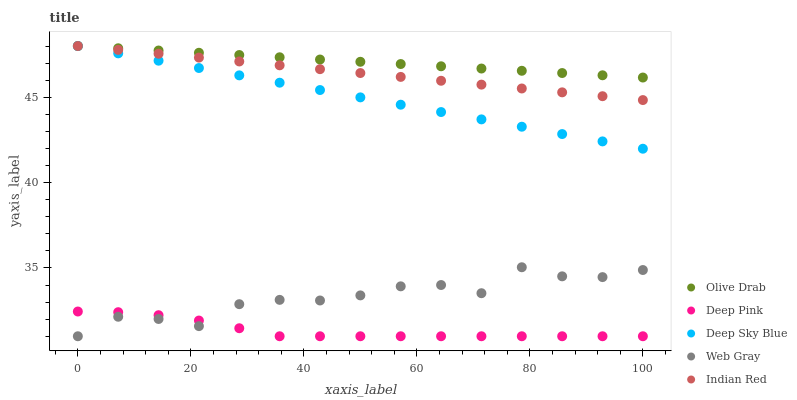Does Deep Pink have the minimum area under the curve?
Answer yes or no. Yes. Does Olive Drab have the maximum area under the curve?
Answer yes or no. Yes. Does Web Gray have the minimum area under the curve?
Answer yes or no. No. Does Web Gray have the maximum area under the curve?
Answer yes or no. No. Is Olive Drab the smoothest?
Answer yes or no. Yes. Is Web Gray the roughest?
Answer yes or no. Yes. Is Deep Pink the smoothest?
Answer yes or no. No. Is Deep Pink the roughest?
Answer yes or no. No. Does Deep Pink have the lowest value?
Answer yes or no. Yes. Does Deep Sky Blue have the lowest value?
Answer yes or no. No. Does Olive Drab have the highest value?
Answer yes or no. Yes. Does Web Gray have the highest value?
Answer yes or no. No. Is Deep Pink less than Indian Red?
Answer yes or no. Yes. Is Indian Red greater than Web Gray?
Answer yes or no. Yes. Does Deep Sky Blue intersect Indian Red?
Answer yes or no. Yes. Is Deep Sky Blue less than Indian Red?
Answer yes or no. No. Is Deep Sky Blue greater than Indian Red?
Answer yes or no. No. Does Deep Pink intersect Indian Red?
Answer yes or no. No. 